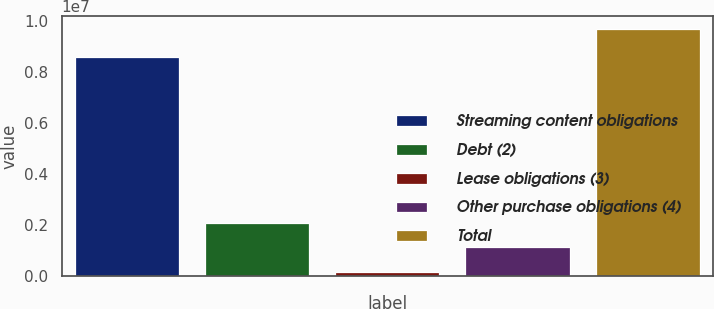Convert chart. <chart><loc_0><loc_0><loc_500><loc_500><bar_chart><fcel>Streaming content obligations<fcel>Debt (2)<fcel>Lease obligations (3)<fcel>Other purchase obligations (4)<fcel>Total<nl><fcel>8.6114e+06<fcel>2.08063e+06<fcel>172470<fcel>1.12655e+06<fcel>9.71328e+06<nl></chart> 